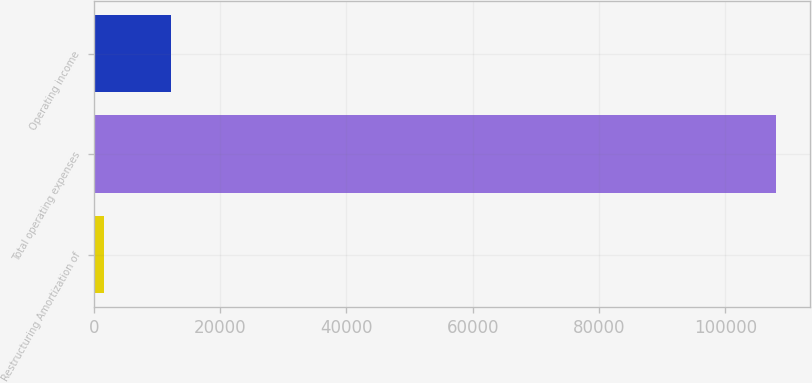Convert chart to OTSL. <chart><loc_0><loc_0><loc_500><loc_500><bar_chart><fcel>Restructuring Amortization of<fcel>Total operating expenses<fcel>Operating income<nl><fcel>1643<fcel>108092<fcel>12287.9<nl></chart> 